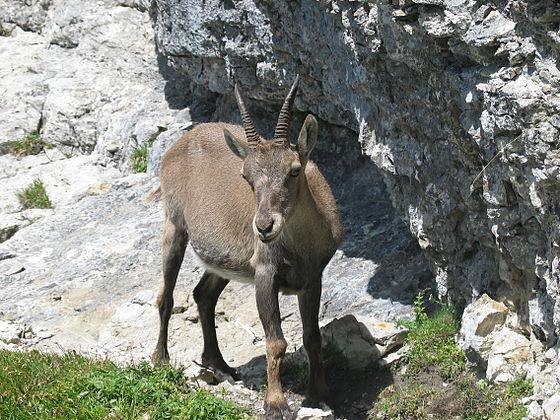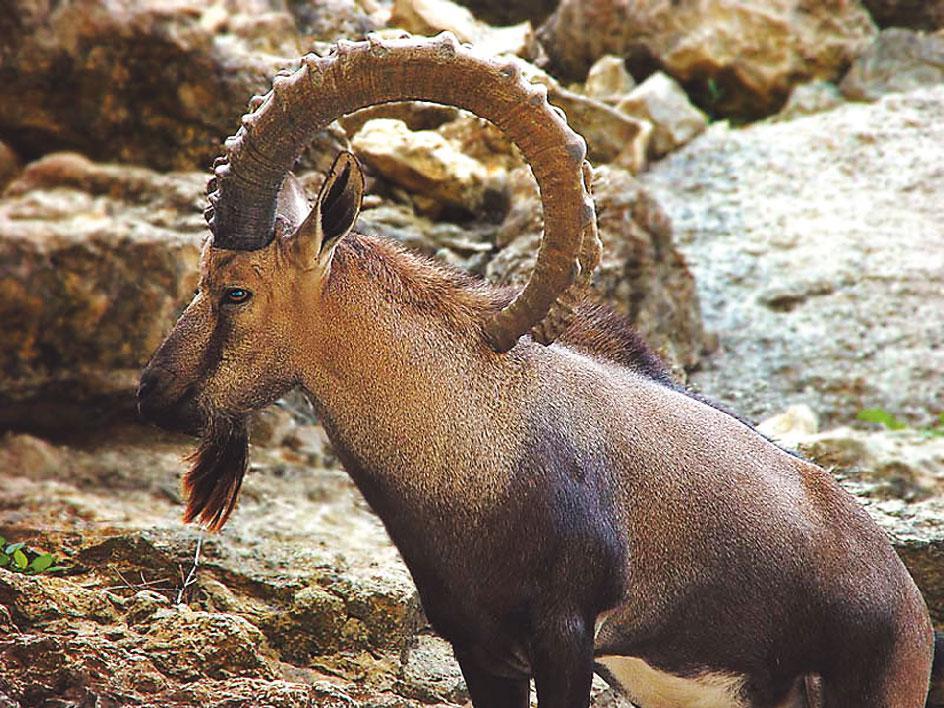The first image is the image on the left, the second image is the image on the right. Given the left and right images, does the statement "There is an animal lying on the ground in one of the images." hold true? Answer yes or no. No. 